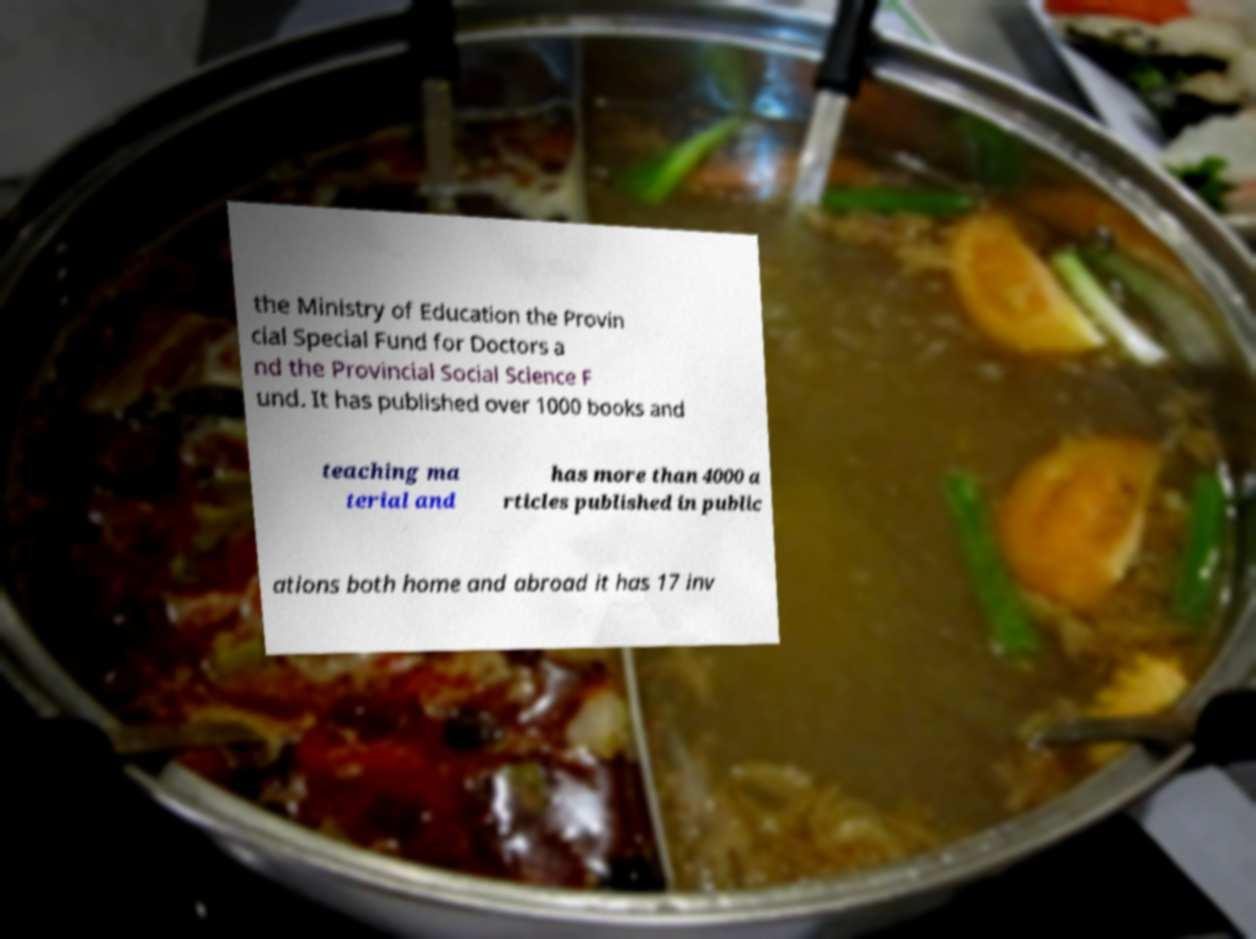What messages or text are displayed in this image? I need them in a readable, typed format. the Ministry of Education the Provin cial Special Fund for Doctors a nd the Provincial Social Science F und. It has published over 1000 books and teaching ma terial and has more than 4000 a rticles published in public ations both home and abroad it has 17 inv 